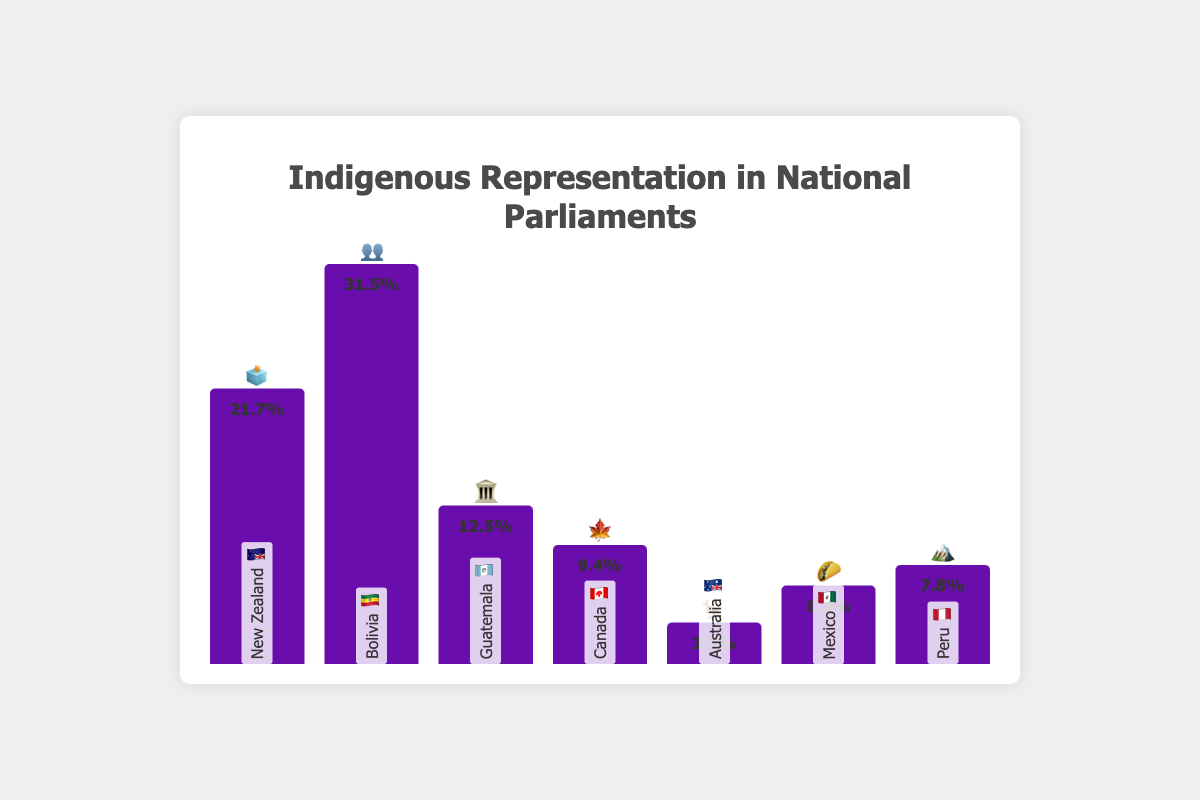Who has the highest indigenous representation in parliament? The figure shows several countries with varying degrees of indigenous representation, but Bolivia 🇧🇴 has the tallest bar, indicating the highest percentage representation of 31.5%.
Answer: Bolivia 🇧🇴 What percentage of indigenous representation does New Zealand 🇳🇿 have? By looking at the bar for New Zealand 🇳🇿, one can see the value labeled as 21.7%.
Answer: 21.7% How does Canada's 🇨🇦 indigenous representation compare to Mexico's 🇲🇽? Canada's representation is marked as 9.4%, while Mexico's is 6.2%. Therefore, Canada's representation is higher than Mexico's.
Answer: Canada 🇨🇦 has higher representation than Mexico 🇲🇽 Which countries have less than 10% indigenous representation? Analyzing the bars, we find that Australia 🇦🇺 (3.3%), Mexico 🇲🇽 (6.2%), and Canada 🇨🇦 (9.4%) are the countries with less than 10% representation.
Answer: Australia 🇦🇺, Mexico 🇲🇽, Canada 🇨🇦 What is the average indigenous representation among the countries listed? The percentages are Bolivia 🇧🇴 (31.5%), New Zealand 🇳🇿 (21.7%), Guatemala 🇬🇹 (12.5%), Canada 🇨🇦 (9.4%), Australia 🇦🇺 (3.3%), Mexico 🇲🇽 (6.2%), and Peru 🇵🇪 (7.8%). Summing these gives 92.4%, and dividing by 7 countries results in an average of approximately 13.2%.
Answer: 13.2% How much more is Bolivia's 🇧🇴 indigenous representation compared to Australia's 🇦🇺? Bolivia 🇧🇴 has 31.5%, whereas Australia 🇦🇺 has 3.3%. The difference is 31.5% - 3.3% = 28.2%.
Answer: 28.2% Which countries have more than 20% indigenous representation? The countries above 20% are Bolivia 🇧🇴 (31.5%) and New Zealand 🇳🇿 (21.7%).
Answer: Bolivia 🇧🇴, New Zealand 🇳🇿 What is the total indigenous representation among New Zealand 🇳🇿, Peru 🇵🇪, and Guatemala 🇬🇹 combined? Looking at the percentages for these countries: New Zealand 🇳🇿 (21.7%), Peru 🇵🇪 (7.8%), and Guatemala 🇬🇹 (12.5%), the total is 21.7% + 7.8% + 12.5% = 42%.
Answer: 42% Arrange the countries in descending order of their indigenous representation. From the chart, descending order would be: Bolivia 🇧🇴 (31.5%), New Zealand 🇳🇿 (21.7%), Guatemala 🇬🇹 (12.5%), Canada 🇨🇦 (9.4%), Peru 🇵🇪 (7.8%), Mexico 🇲🇽 (6.2%), Australia 🇦🇺 (3.3%).
Answer: Bolivia 🇧🇴, New Zealand 🇳🇿, Guatemala 🇬🇹, Canada 🇨🇦, Peru 🇵🇪, Mexico 🇲🇽, Australia 🇦🇺 